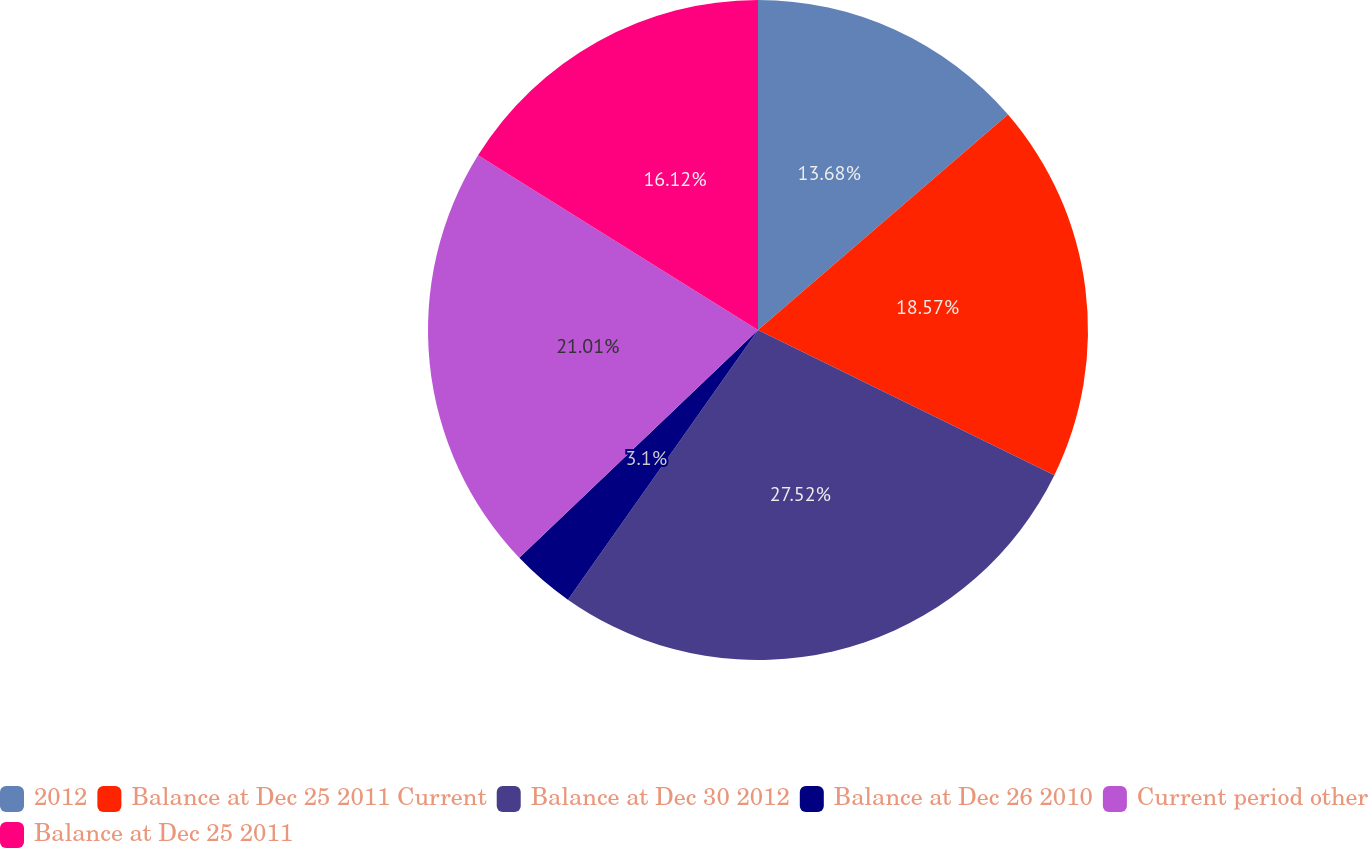Convert chart to OTSL. <chart><loc_0><loc_0><loc_500><loc_500><pie_chart><fcel>2012<fcel>Balance at Dec 25 2011 Current<fcel>Balance at Dec 30 2012<fcel>Balance at Dec 26 2010<fcel>Current period other<fcel>Balance at Dec 25 2011<nl><fcel>13.68%<fcel>18.57%<fcel>27.52%<fcel>3.1%<fcel>21.01%<fcel>16.12%<nl></chart> 